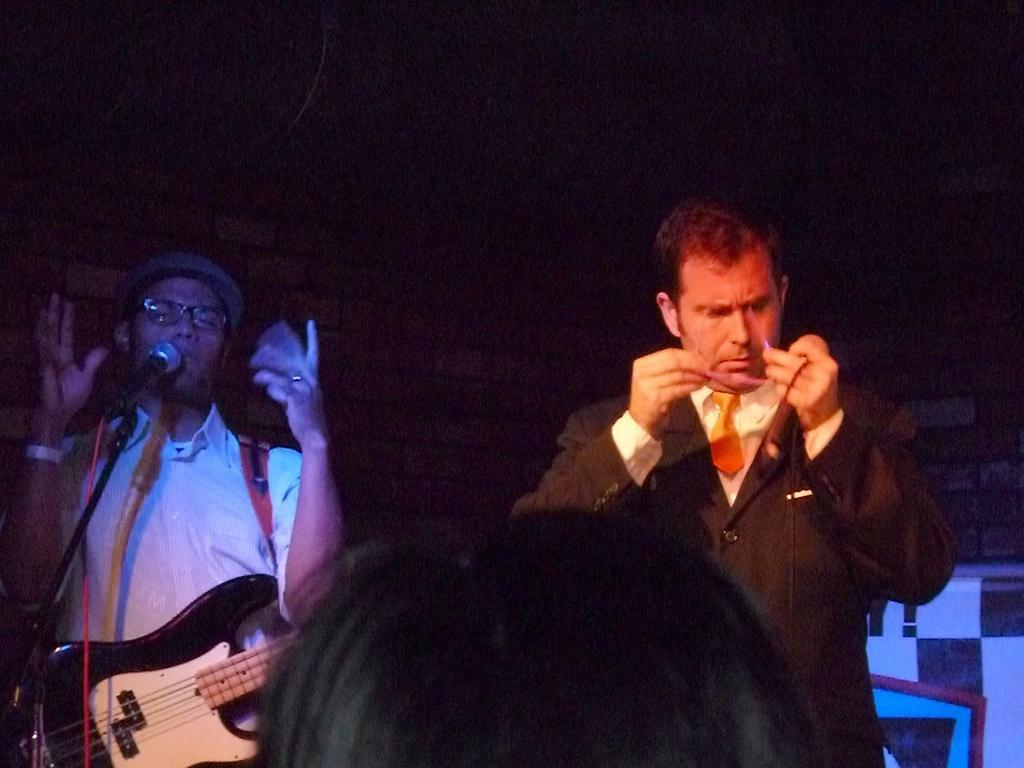Describe this image in one or two sentences. In this image I can see two persons standing. In front the person is wearing brown blazer, cream color shirt and an orange color tie and the person at left is wearing white color shirt and holding the musical instrument and I can see the microphone and I can see the dark background. 